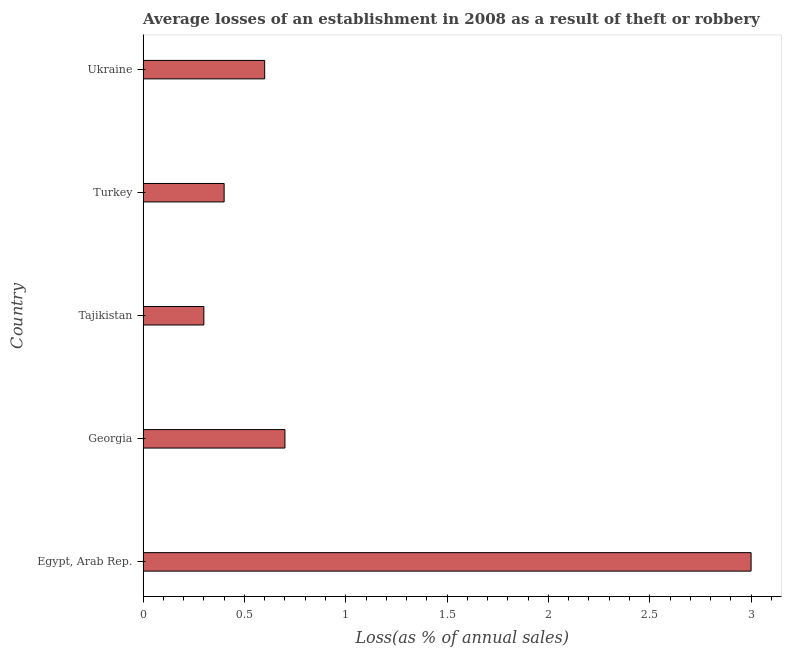What is the title of the graph?
Give a very brief answer. Average losses of an establishment in 2008 as a result of theft or robbery. What is the label or title of the X-axis?
Your response must be concise. Loss(as % of annual sales). What is the losses due to theft in Tajikistan?
Offer a very short reply. 0.3. Across all countries, what is the minimum losses due to theft?
Provide a succinct answer. 0.3. In which country was the losses due to theft maximum?
Your answer should be very brief. Egypt, Arab Rep. In which country was the losses due to theft minimum?
Make the answer very short. Tajikistan. What is the sum of the losses due to theft?
Offer a very short reply. 5. What is the difference between the losses due to theft in Georgia and Tajikistan?
Offer a terse response. 0.4. What is the median losses due to theft?
Give a very brief answer. 0.6. What is the ratio of the losses due to theft in Georgia to that in Turkey?
Offer a very short reply. 1.75. Is the sum of the losses due to theft in Turkey and Ukraine greater than the maximum losses due to theft across all countries?
Offer a very short reply. No. How many bars are there?
Your answer should be very brief. 5. Are all the bars in the graph horizontal?
Make the answer very short. Yes. What is the difference between two consecutive major ticks on the X-axis?
Provide a short and direct response. 0.5. What is the Loss(as % of annual sales) of Egypt, Arab Rep.?
Your answer should be very brief. 3. What is the Loss(as % of annual sales) of Georgia?
Offer a terse response. 0.7. What is the Loss(as % of annual sales) of Turkey?
Keep it short and to the point. 0.4. What is the Loss(as % of annual sales) in Ukraine?
Your response must be concise. 0.6. What is the difference between the Loss(as % of annual sales) in Egypt, Arab Rep. and Georgia?
Keep it short and to the point. 2.3. What is the difference between the Loss(as % of annual sales) in Egypt, Arab Rep. and Tajikistan?
Provide a succinct answer. 2.7. What is the difference between the Loss(as % of annual sales) in Egypt, Arab Rep. and Ukraine?
Make the answer very short. 2.4. What is the difference between the Loss(as % of annual sales) in Georgia and Tajikistan?
Make the answer very short. 0.4. What is the difference between the Loss(as % of annual sales) in Georgia and Turkey?
Offer a very short reply. 0.3. What is the difference between the Loss(as % of annual sales) in Georgia and Ukraine?
Give a very brief answer. 0.1. What is the difference between the Loss(as % of annual sales) in Turkey and Ukraine?
Provide a succinct answer. -0.2. What is the ratio of the Loss(as % of annual sales) in Egypt, Arab Rep. to that in Georgia?
Provide a short and direct response. 4.29. What is the ratio of the Loss(as % of annual sales) in Egypt, Arab Rep. to that in Turkey?
Your answer should be very brief. 7.5. What is the ratio of the Loss(as % of annual sales) in Egypt, Arab Rep. to that in Ukraine?
Make the answer very short. 5. What is the ratio of the Loss(as % of annual sales) in Georgia to that in Tajikistan?
Keep it short and to the point. 2.33. What is the ratio of the Loss(as % of annual sales) in Georgia to that in Turkey?
Offer a terse response. 1.75. What is the ratio of the Loss(as % of annual sales) in Georgia to that in Ukraine?
Offer a terse response. 1.17. What is the ratio of the Loss(as % of annual sales) in Tajikistan to that in Ukraine?
Offer a very short reply. 0.5. What is the ratio of the Loss(as % of annual sales) in Turkey to that in Ukraine?
Offer a terse response. 0.67. 